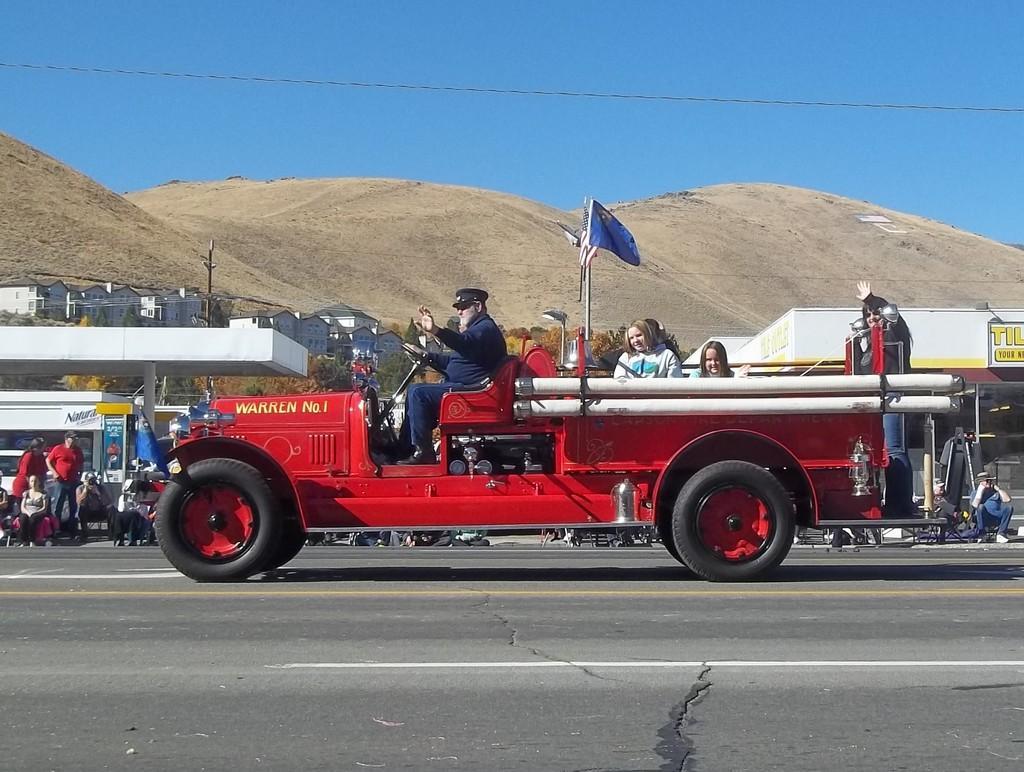How would you summarize this image in a sentence or two? In this image, we can see persons and flag in the vehicle. There are buildings and hills in the middle of the image. There is a sky at the top of the image. 